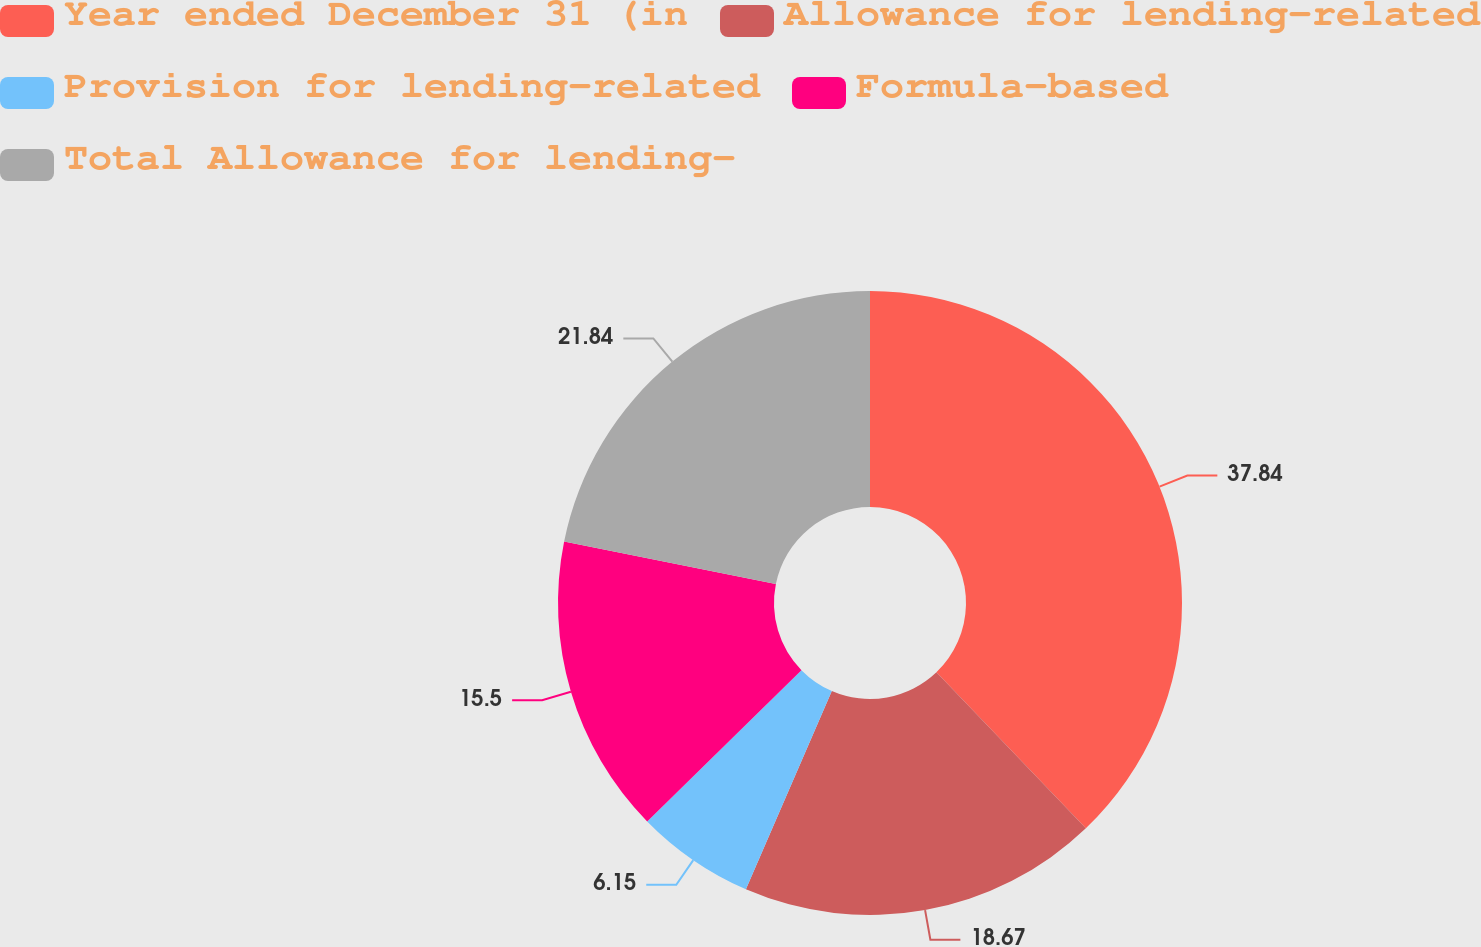<chart> <loc_0><loc_0><loc_500><loc_500><pie_chart><fcel>Year ended December 31 (in<fcel>Allowance for lending-related<fcel>Provision for lending-related<fcel>Formula-based<fcel>Total Allowance for lending-<nl><fcel>37.84%<fcel>18.67%<fcel>6.15%<fcel>15.5%<fcel>21.84%<nl></chart> 